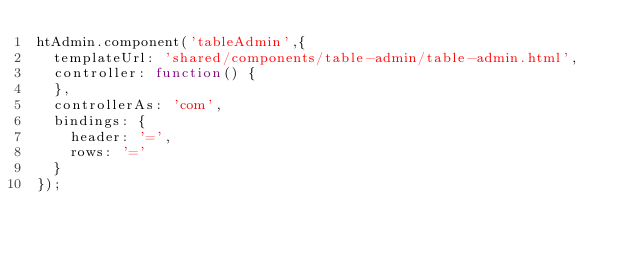<code> <loc_0><loc_0><loc_500><loc_500><_JavaScript_>htAdmin.component('tableAdmin',{
	templateUrl: 'shared/components/table-admin/table-admin.html',
	controller: function() {
	},
	controllerAs: 'com',
	bindings: {
		header: '=',
		rows: '='
	}
});
</code> 